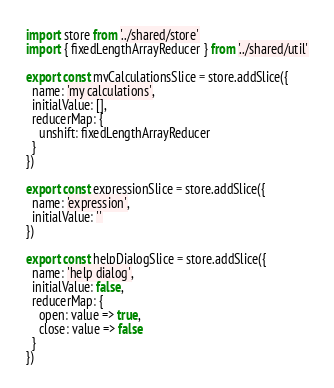Convert code to text. <code><loc_0><loc_0><loc_500><loc_500><_JavaScript_>import store from '../shared/store'
import { fixedLengthArrayReducer } from '../shared/util'

export const myCalculationsSlice = store.addSlice({
  name: 'my calculations',
  initialValue: [],
  reducerMap: {
    unshift: fixedLengthArrayReducer
  }
})

export const expressionSlice = store.addSlice({
  name: 'expression',
  initialValue: ''
})

export const helpDialogSlice = store.addSlice({
  name: 'help dialog',
  initialValue: false,
  reducerMap: {
    open: value => true,
    close: value => false
  }
})
</code> 